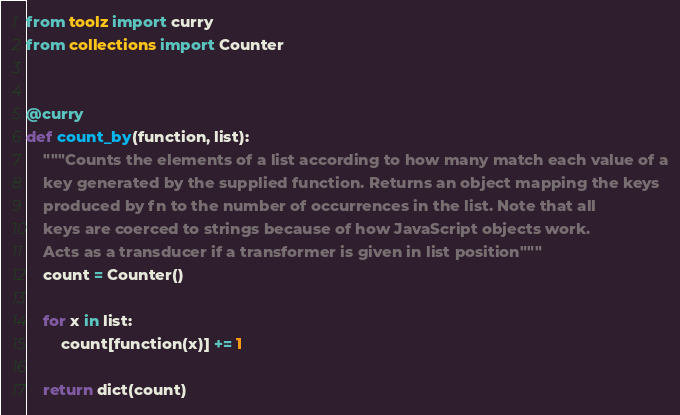<code> <loc_0><loc_0><loc_500><loc_500><_Python_>from toolz import curry
from collections import Counter


@curry
def count_by(function, list):
    """Counts the elements of a list according to how many match each value of a
    key generated by the supplied function. Returns an object mapping the keys
    produced by fn to the number of occurrences in the list. Note that all
    keys are coerced to strings because of how JavaScript objects work.
    Acts as a transducer if a transformer is given in list position"""
    count = Counter()

    for x in list:
        count[function(x)] += 1

    return dict(count)
</code> 